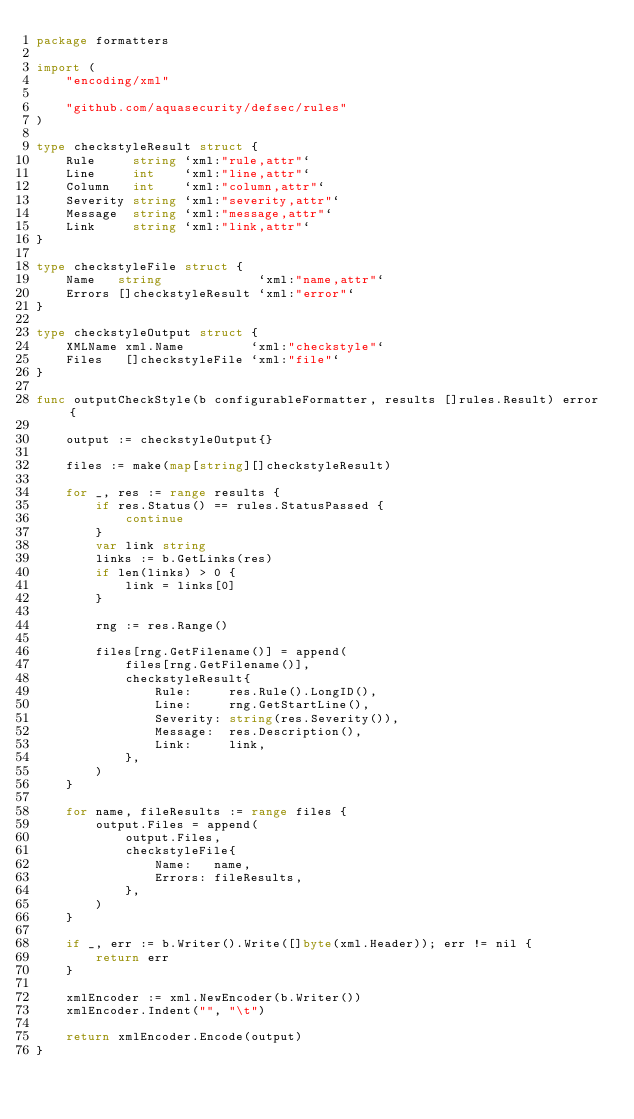Convert code to text. <code><loc_0><loc_0><loc_500><loc_500><_Go_>package formatters

import (
	"encoding/xml"

	"github.com/aquasecurity/defsec/rules"
)

type checkstyleResult struct {
	Rule     string `xml:"rule,attr"`
	Line     int    `xml:"line,attr"`
	Column   int    `xml:"column,attr"`
	Severity string `xml:"severity,attr"`
	Message  string `xml:"message,attr"`
	Link     string `xml:"link,attr"`
}

type checkstyleFile struct {
	Name   string             `xml:"name,attr"`
	Errors []checkstyleResult `xml:"error"`
}

type checkstyleOutput struct {
	XMLName xml.Name         `xml:"checkstyle"`
	Files   []checkstyleFile `xml:"file"`
}

func outputCheckStyle(b configurableFormatter, results []rules.Result) error {

	output := checkstyleOutput{}

	files := make(map[string][]checkstyleResult)

	for _, res := range results {
		if res.Status() == rules.StatusPassed {
			continue
		}
		var link string
		links := b.GetLinks(res)
		if len(links) > 0 {
			link = links[0]
		}

		rng := res.Range()

		files[rng.GetFilename()] = append(
			files[rng.GetFilename()],
			checkstyleResult{
				Rule:     res.Rule().LongID(),
				Line:     rng.GetStartLine(),
				Severity: string(res.Severity()),
				Message:  res.Description(),
				Link:     link,
			},
		)
	}

	for name, fileResults := range files {
		output.Files = append(
			output.Files,
			checkstyleFile{
				Name:   name,
				Errors: fileResults,
			},
		)
	}

	if _, err := b.Writer().Write([]byte(xml.Header)); err != nil {
		return err
	}

	xmlEncoder := xml.NewEncoder(b.Writer())
	xmlEncoder.Indent("", "\t")

	return xmlEncoder.Encode(output)
}
</code> 